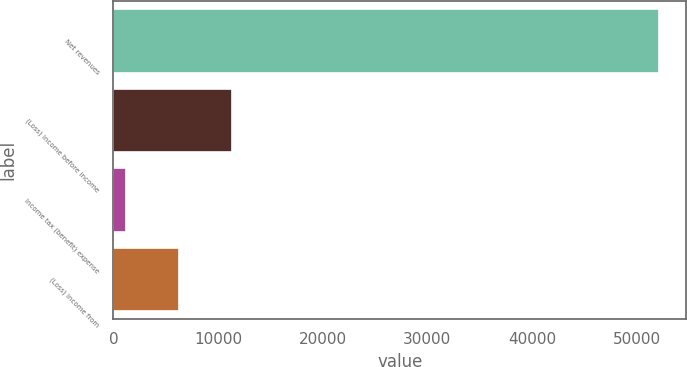<chart> <loc_0><loc_0><loc_500><loc_500><bar_chart><fcel>Net revenues<fcel>(Loss) income before income<fcel>Income tax (benefit) expense<fcel>(Loss) income from<nl><fcel>52139<fcel>11370.2<fcel>1178<fcel>6274.1<nl></chart> 